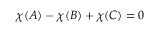Convert formula to latex. <formula><loc_0><loc_0><loc_500><loc_500>\chi ( A ) - \chi ( B ) + \chi ( C ) = 0</formula> 